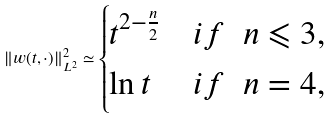Convert formula to latex. <formula><loc_0><loc_0><loc_500><loc_500>\| w ( t , \cdot ) \| _ { L ^ { 2 } } ^ { 2 } \simeq \begin{cases} t ^ { 2 - \frac { n } { 2 } } & i f \ \ n \leqslant 3 , \\ \ln t & i f \ \ n = 4 , \end{cases}</formula> 